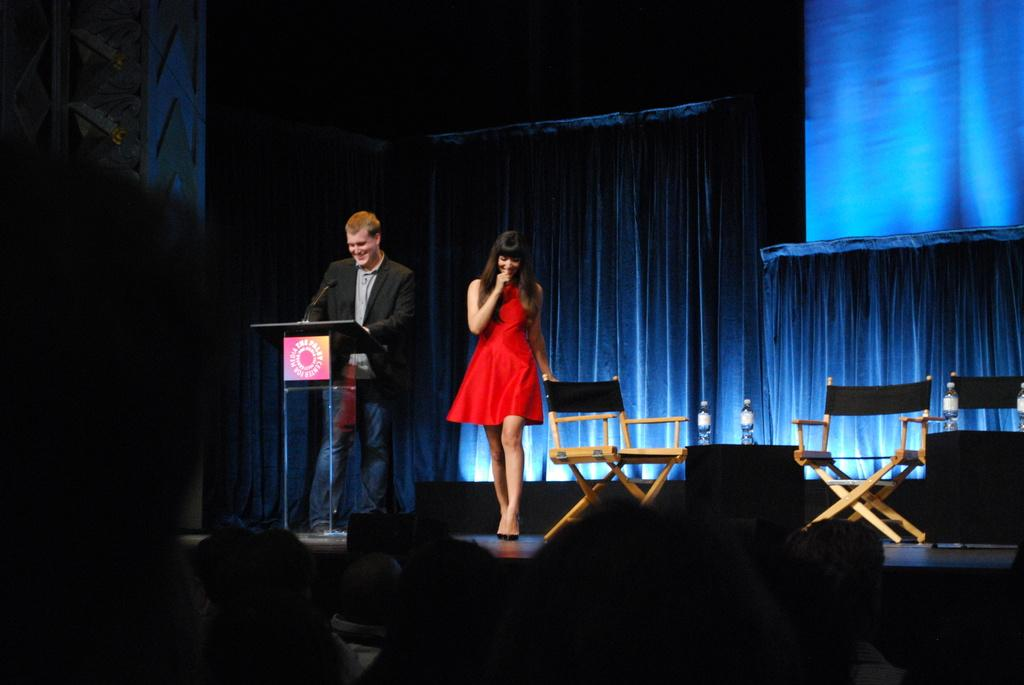What is the man doing on the left side of the image? The man is standing on the left side of the image. What is the man wearing in the image? The man is wearing a coat in the image. What is the girl doing in the middle of the image? The girl is walking in the middle of the image. What is the girl wearing in the image? The girl is wearing a red color dress in the image. What can be seen on the right side of the image? There are chairs on the stage on the right side of the image. What is the rate of wool production in the image? There is no mention of wool or its production in the image. What historical event is depicted in the image? The image does not depict any historical event; it shows a man, a girl, and chairs on a stage. 